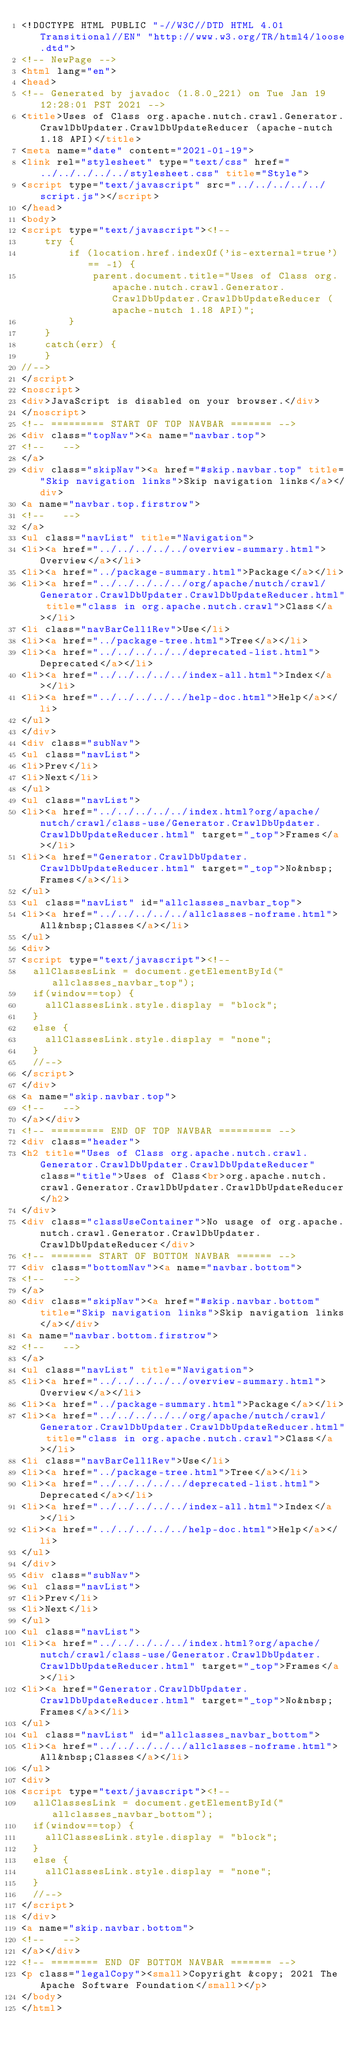<code> <loc_0><loc_0><loc_500><loc_500><_HTML_><!DOCTYPE HTML PUBLIC "-//W3C//DTD HTML 4.01 Transitional//EN" "http://www.w3.org/TR/html4/loose.dtd">
<!-- NewPage -->
<html lang="en">
<head>
<!-- Generated by javadoc (1.8.0_221) on Tue Jan 19 12:28:01 PST 2021 -->
<title>Uses of Class org.apache.nutch.crawl.Generator.CrawlDbUpdater.CrawlDbUpdateReducer (apache-nutch 1.18 API)</title>
<meta name="date" content="2021-01-19">
<link rel="stylesheet" type="text/css" href="../../../../../stylesheet.css" title="Style">
<script type="text/javascript" src="../../../../../script.js"></script>
</head>
<body>
<script type="text/javascript"><!--
    try {
        if (location.href.indexOf('is-external=true') == -1) {
            parent.document.title="Uses of Class org.apache.nutch.crawl.Generator.CrawlDbUpdater.CrawlDbUpdateReducer (apache-nutch 1.18 API)";
        }
    }
    catch(err) {
    }
//-->
</script>
<noscript>
<div>JavaScript is disabled on your browser.</div>
</noscript>
<!-- ========= START OF TOP NAVBAR ======= -->
<div class="topNav"><a name="navbar.top">
<!--   -->
</a>
<div class="skipNav"><a href="#skip.navbar.top" title="Skip navigation links">Skip navigation links</a></div>
<a name="navbar.top.firstrow">
<!--   -->
</a>
<ul class="navList" title="Navigation">
<li><a href="../../../../../overview-summary.html">Overview</a></li>
<li><a href="../package-summary.html">Package</a></li>
<li><a href="../../../../../org/apache/nutch/crawl/Generator.CrawlDbUpdater.CrawlDbUpdateReducer.html" title="class in org.apache.nutch.crawl">Class</a></li>
<li class="navBarCell1Rev">Use</li>
<li><a href="../package-tree.html">Tree</a></li>
<li><a href="../../../../../deprecated-list.html">Deprecated</a></li>
<li><a href="../../../../../index-all.html">Index</a></li>
<li><a href="../../../../../help-doc.html">Help</a></li>
</ul>
</div>
<div class="subNav">
<ul class="navList">
<li>Prev</li>
<li>Next</li>
</ul>
<ul class="navList">
<li><a href="../../../../../index.html?org/apache/nutch/crawl/class-use/Generator.CrawlDbUpdater.CrawlDbUpdateReducer.html" target="_top">Frames</a></li>
<li><a href="Generator.CrawlDbUpdater.CrawlDbUpdateReducer.html" target="_top">No&nbsp;Frames</a></li>
</ul>
<ul class="navList" id="allclasses_navbar_top">
<li><a href="../../../../../allclasses-noframe.html">All&nbsp;Classes</a></li>
</ul>
<div>
<script type="text/javascript"><!--
  allClassesLink = document.getElementById("allclasses_navbar_top");
  if(window==top) {
    allClassesLink.style.display = "block";
  }
  else {
    allClassesLink.style.display = "none";
  }
  //-->
</script>
</div>
<a name="skip.navbar.top">
<!--   -->
</a></div>
<!-- ========= END OF TOP NAVBAR ========= -->
<div class="header">
<h2 title="Uses of Class org.apache.nutch.crawl.Generator.CrawlDbUpdater.CrawlDbUpdateReducer" class="title">Uses of Class<br>org.apache.nutch.crawl.Generator.CrawlDbUpdater.CrawlDbUpdateReducer</h2>
</div>
<div class="classUseContainer">No usage of org.apache.nutch.crawl.Generator.CrawlDbUpdater.CrawlDbUpdateReducer</div>
<!-- ======= START OF BOTTOM NAVBAR ====== -->
<div class="bottomNav"><a name="navbar.bottom">
<!--   -->
</a>
<div class="skipNav"><a href="#skip.navbar.bottom" title="Skip navigation links">Skip navigation links</a></div>
<a name="navbar.bottom.firstrow">
<!--   -->
</a>
<ul class="navList" title="Navigation">
<li><a href="../../../../../overview-summary.html">Overview</a></li>
<li><a href="../package-summary.html">Package</a></li>
<li><a href="../../../../../org/apache/nutch/crawl/Generator.CrawlDbUpdater.CrawlDbUpdateReducer.html" title="class in org.apache.nutch.crawl">Class</a></li>
<li class="navBarCell1Rev">Use</li>
<li><a href="../package-tree.html">Tree</a></li>
<li><a href="../../../../../deprecated-list.html">Deprecated</a></li>
<li><a href="../../../../../index-all.html">Index</a></li>
<li><a href="../../../../../help-doc.html">Help</a></li>
</ul>
</div>
<div class="subNav">
<ul class="navList">
<li>Prev</li>
<li>Next</li>
</ul>
<ul class="navList">
<li><a href="../../../../../index.html?org/apache/nutch/crawl/class-use/Generator.CrawlDbUpdater.CrawlDbUpdateReducer.html" target="_top">Frames</a></li>
<li><a href="Generator.CrawlDbUpdater.CrawlDbUpdateReducer.html" target="_top">No&nbsp;Frames</a></li>
</ul>
<ul class="navList" id="allclasses_navbar_bottom">
<li><a href="../../../../../allclasses-noframe.html">All&nbsp;Classes</a></li>
</ul>
<div>
<script type="text/javascript"><!--
  allClassesLink = document.getElementById("allclasses_navbar_bottom");
  if(window==top) {
    allClassesLink.style.display = "block";
  }
  else {
    allClassesLink.style.display = "none";
  }
  //-->
</script>
</div>
<a name="skip.navbar.bottom">
<!--   -->
</a></div>
<!-- ======== END OF BOTTOM NAVBAR ======= -->
<p class="legalCopy"><small>Copyright &copy; 2021 The Apache Software Foundation</small></p>
</body>
</html>
</code> 